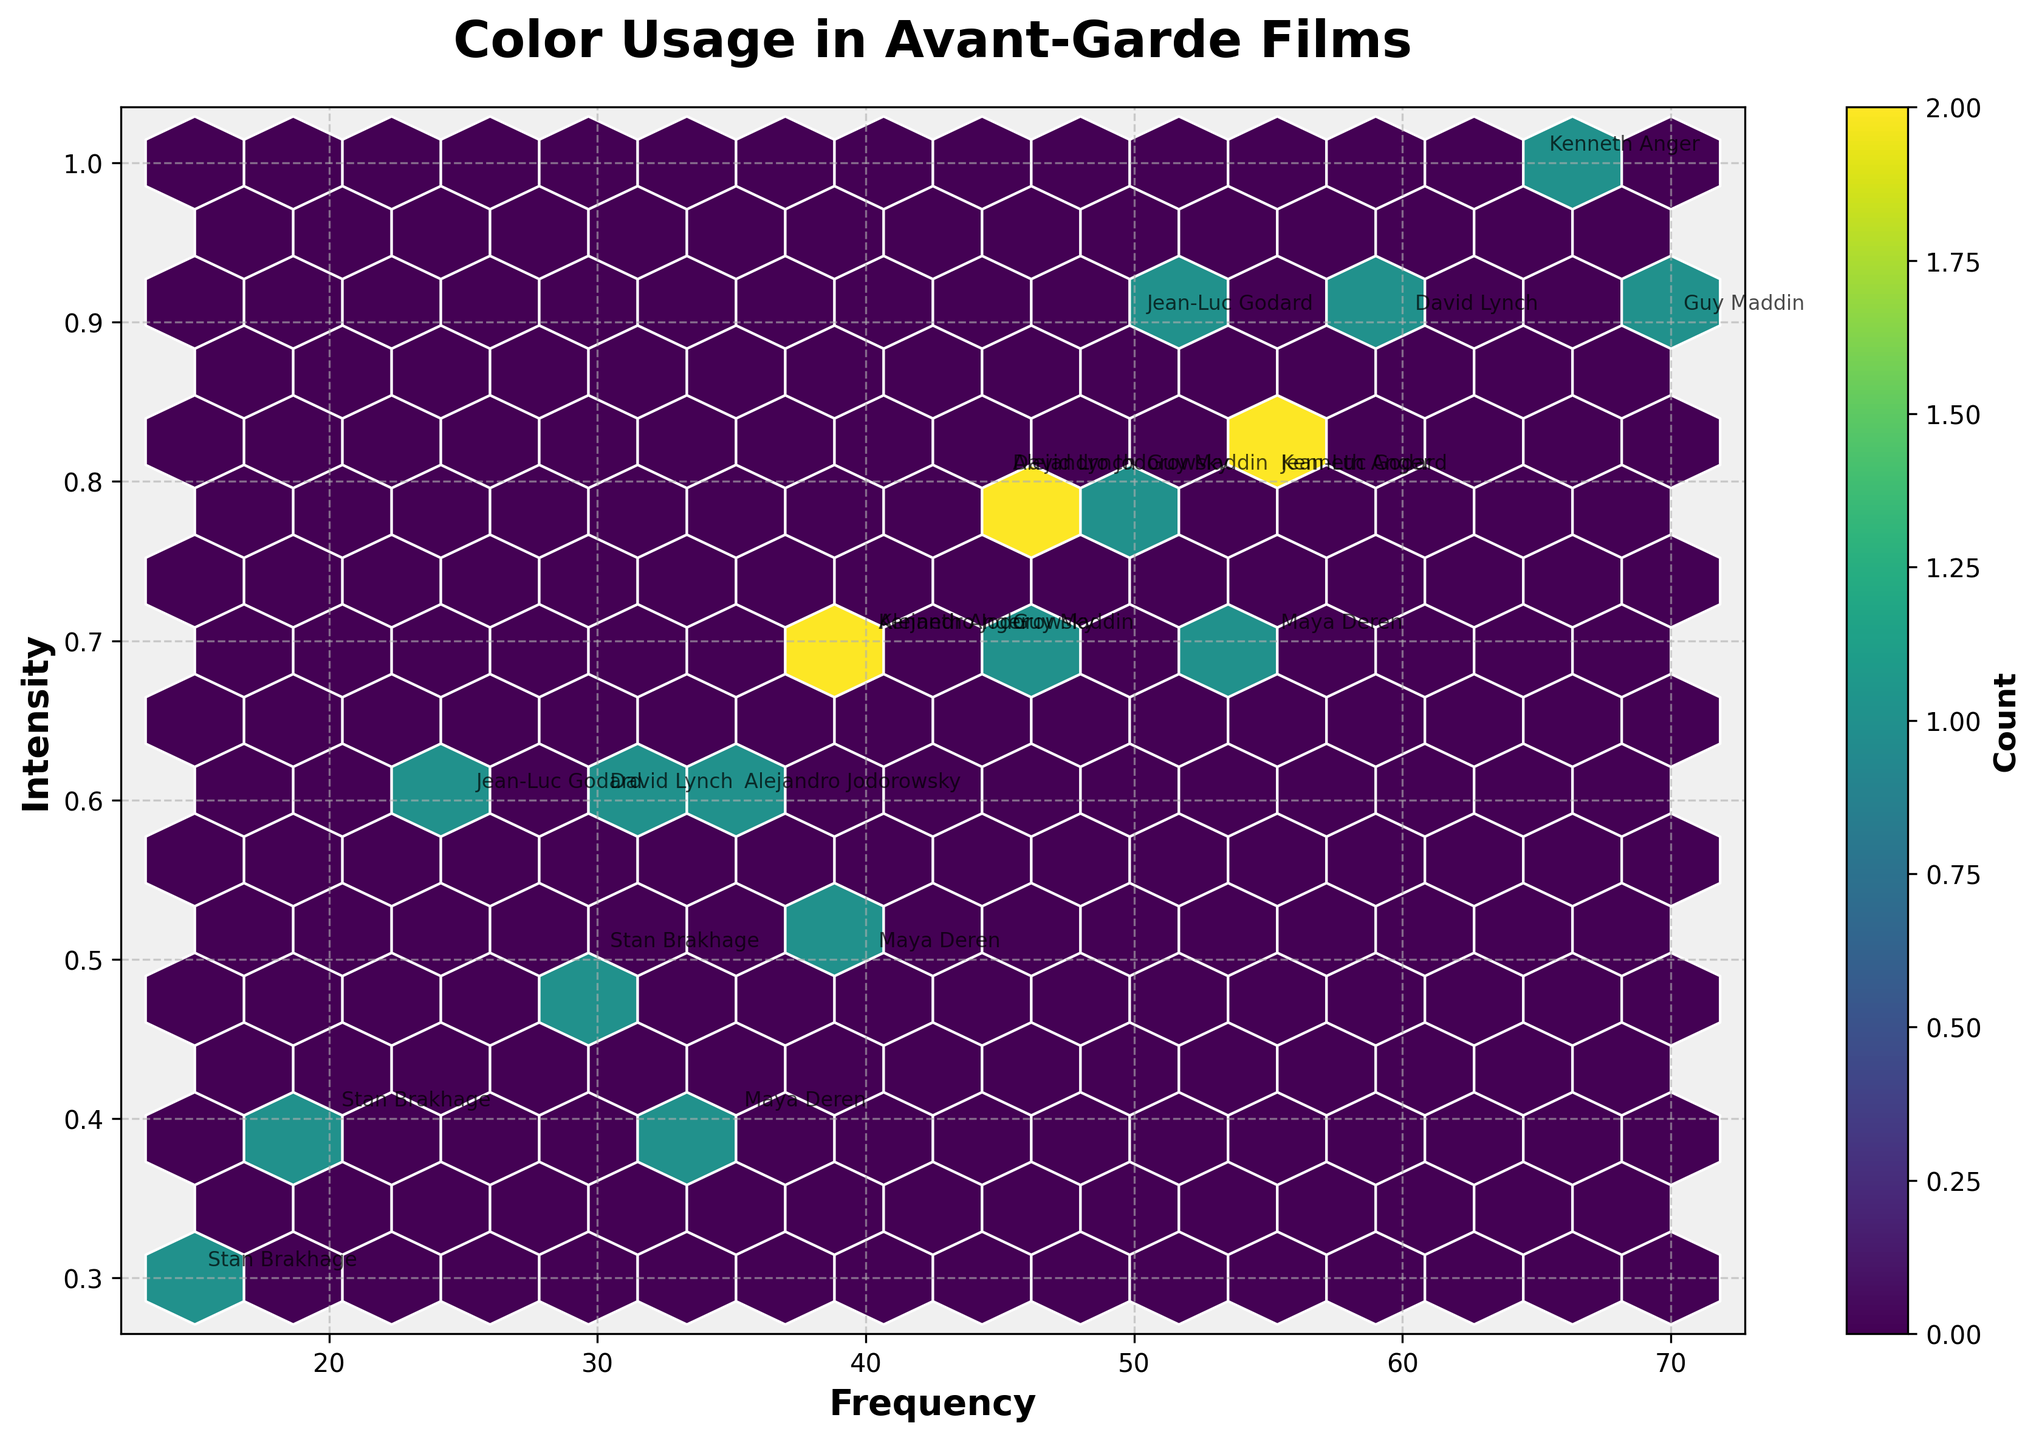What is the title of the plot? The title is typically displayed at the top of the plot, in this case, it's "Color Usage in Avant-Garde Films".
Answer: Color Usage in Avant-Garde Films What are the labels for the X and Y axes? X and Y axis labels are usually shown along the axes. Here, the X-axis is labeled "Frequency" and the Y-axis is labeled "Intensity".
Answer: Frequency and Intensity How many directors are annotated in the plot? Each director's name is annotated near their respective data point. By counting these annotations, we see there are six directors.
Answer: Six Which color has the highest count of occurrences in the plot? The color associated with the highest count in the colorbar indicates the most frequent hexagon. Observing the colorbar and hexagons, the color with the darkest shade (dark blue) represents the highest count.
Answer: Dark blue What combination of frequency and intensity appears most often in the hexbin plot? The most common combination will align with the most densely colored hexagon. By locating the darkest hexagon, we find the most repeated combination.
Answer: Approximately (50, 0.8) Which director has the highest frequency value for any color? We identify the highest frequency value annotated with a director’s name. This corresponds to "Kenneth Anger" with a frequency of 65 for the color Red.
Answer: Kenneth Anger What is the average frequency of the colors used by David Lynch? Calculate the average by summing David Lynch's frequency values and dividing by the number of data points: (45 + 30 + 60) / 3. The sum is 135 and the average is 45.
Answer: 45 Which director's colors have the highest intensity on average? Calculate the average intensity for each director and compare them. For David Lynch: (0.8+0.6+0.9)/3=0.7667; For Maya Deren: (0.7+0.5+0.4)/3=0.5333; For Jean-Luc Godard: (0.9+0.8+0.6)/3=0.7667; For Stan Brakhage: (0.5+0.4+0.3)/3=0.4; For Kenneth Anger: (1.0+0.7+0.8)/3=0.8333; For Alejandro Jodorowsky: (0.6+0.8+0.7)/3=0.7; For Guy Maddin: (0.9+0.8+0.7)/3=0.8. Kenneth Anger has the highest average intensity.
Answer: Kenneth Anger Which director has the most diverse color usage (in terms of frequency and intensity range)? By examining the range of frequency and intensity, calculate the range for each director. David Lynch: (60-30, 0.9-0.6), Maya Deren: (55-35, 0.7-0.4), Jean-Luc Godard: (55-25, 0.9-0.6), Stan Brakhage: (30-15, 0.5-0.3), Kenneth Anger: (65-40, 1.0-0.7), Alejandro Jodorowsky: (45-35, 0.8-0.6), Guy Maddin: (70-45, 0.9-0.7). David Lynch and Jean-Luc Godard show the widest range.
Answer: David Lynch and Jean-Luc Godard What pattern do you notice with Kenneth Anger's usage of the color black compared to other directors? By comparing black's frequency and intensity values, Kenneth Anger uses black frequently (55 times) with high intensity (0.8). Other directors use black less frequently or with lower intensity, indicating Kenneth Anger's reliance on high-frequency, high-intensity black usage.
Answer: High-frequency and high-intensity usage 